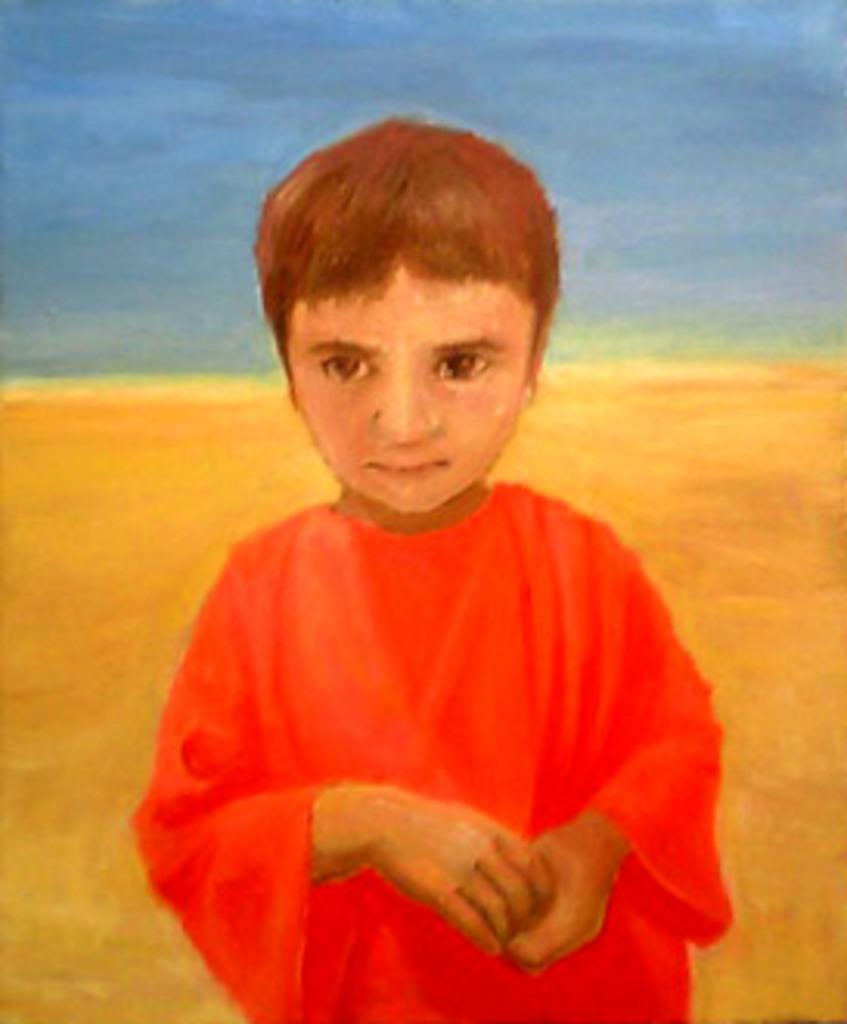Can you describe this image briefly? In this image I can see a painting , on the painting I can see boy wearing a red color dress and in the background I can see blue and yellow color. 